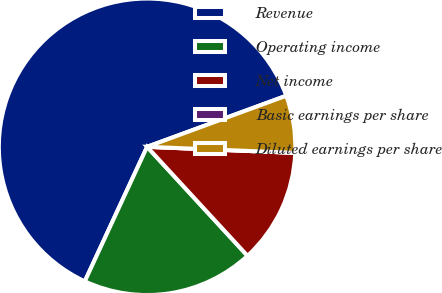Convert chart to OTSL. <chart><loc_0><loc_0><loc_500><loc_500><pie_chart><fcel>Revenue<fcel>Operating income<fcel>Net income<fcel>Basic earnings per share<fcel>Diluted earnings per share<nl><fcel>62.5%<fcel>18.75%<fcel>12.5%<fcel>0.0%<fcel>6.25%<nl></chart> 